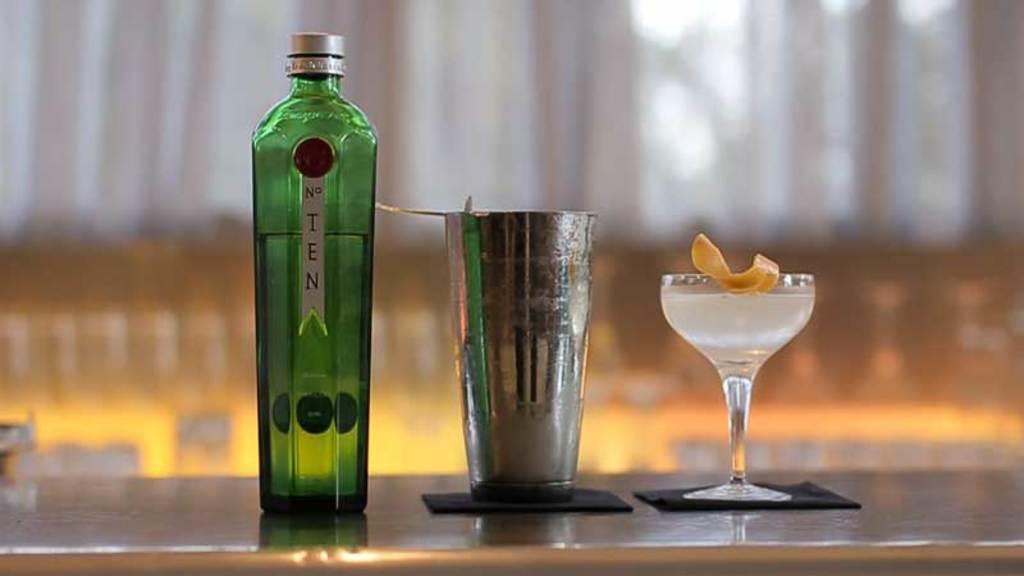What is the left bottle brand?
Ensure brevity in your answer.  Ten. 